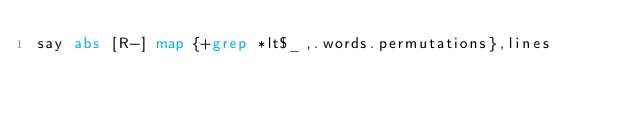<code> <loc_0><loc_0><loc_500><loc_500><_Perl_>say abs [R-] map {+grep *lt$_,.words.permutations},lines</code> 